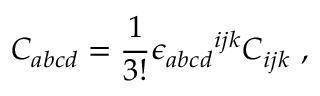Convert formula to latex. <formula><loc_0><loc_0><loc_500><loc_500>C _ { a b c d } = \frac { 1 } { 3 ! } { \epsilon _ { a b c d } } ^ { i j k } C _ { i j k } ,</formula> 